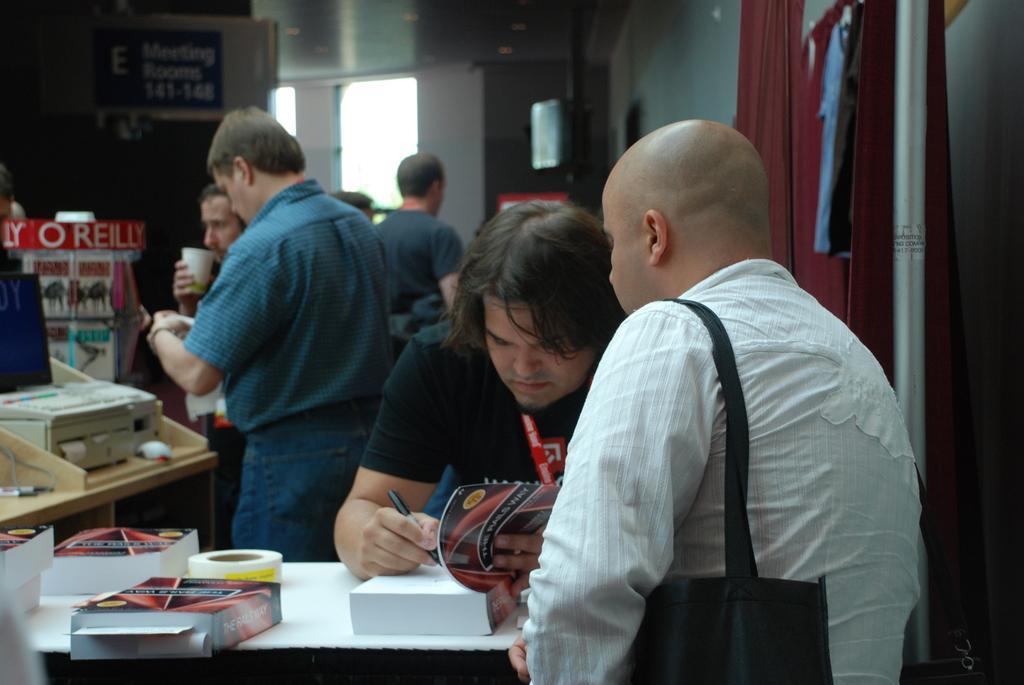Describe this image in one or two sentences. In this picture I can see there are some people standing here and there is a man writing something in the book and there are some books placed here on the table. In the backdrop I can see there are some people drinking some beverage and there is a wall. 